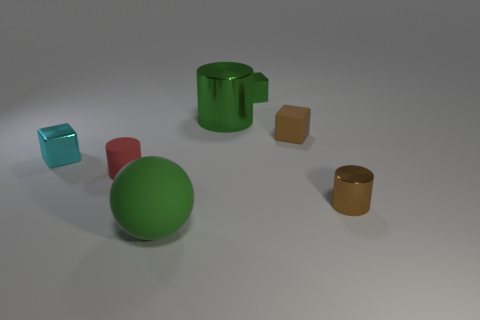Is the material of the small cylinder on the left side of the ball the same as the big thing behind the tiny cyan block?
Your answer should be compact. No. What shape is the shiny object that is in front of the cyan metal cube?
Provide a succinct answer. Cylinder. What size is the brown metal thing that is the same shape as the red thing?
Provide a succinct answer. Small. Do the big cylinder and the small matte cylinder have the same color?
Ensure brevity in your answer.  No. Is there anything else that has the same shape as the red object?
Provide a succinct answer. Yes. There is a small matte thing to the right of the green rubber sphere; are there any tiny cubes that are behind it?
Give a very brief answer. Yes. What is the color of the small matte thing that is the same shape as the brown metallic thing?
Make the answer very short. Red. What number of small metallic things have the same color as the large shiny thing?
Offer a very short reply. 1. What color is the tiny cylinder that is to the left of the green metal object that is in front of the metal thing behind the large cylinder?
Your response must be concise. Red. Do the red thing and the tiny brown cylinder have the same material?
Your answer should be compact. No. 